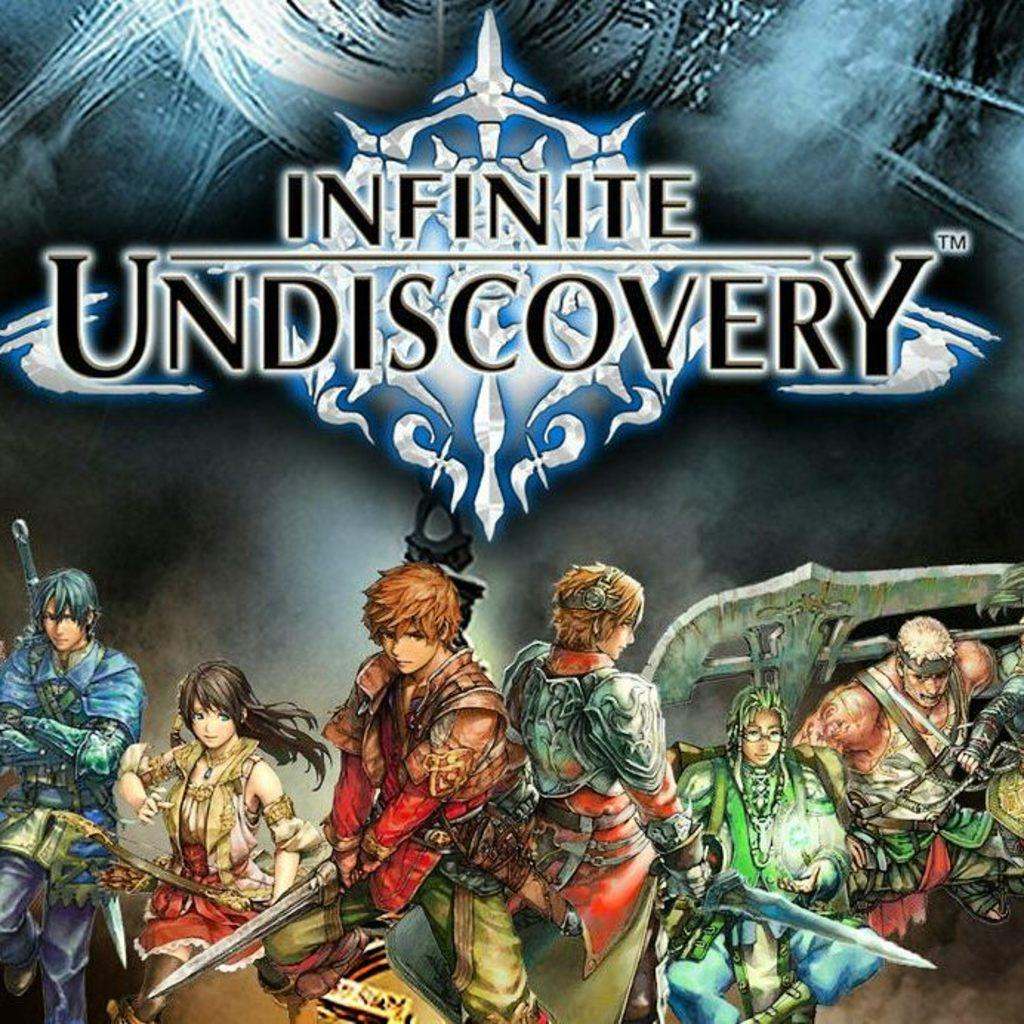<image>
Create a compact narrative representing the image presented. A poster with cartoon characters on it that says Infinite Undiscovery. 